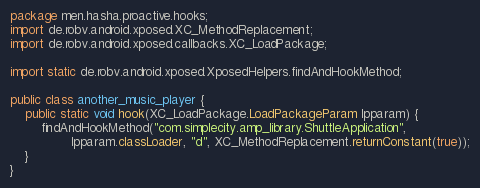<code> <loc_0><loc_0><loc_500><loc_500><_Java_>package men.hasha.proactive.hooks;
import de.robv.android.xposed.XC_MethodReplacement;
import de.robv.android.xposed.callbacks.XC_LoadPackage;

import static de.robv.android.xposed.XposedHelpers.findAndHookMethod;

public class another_music_player {
    public static void hook(XC_LoadPackage.LoadPackageParam lpparam) {
        findAndHookMethod("com.simplecity.amp_library.ShuttleApplication",
                lpparam.classLoader, "d", XC_MethodReplacement.returnConstant(true));
    }
}
</code> 